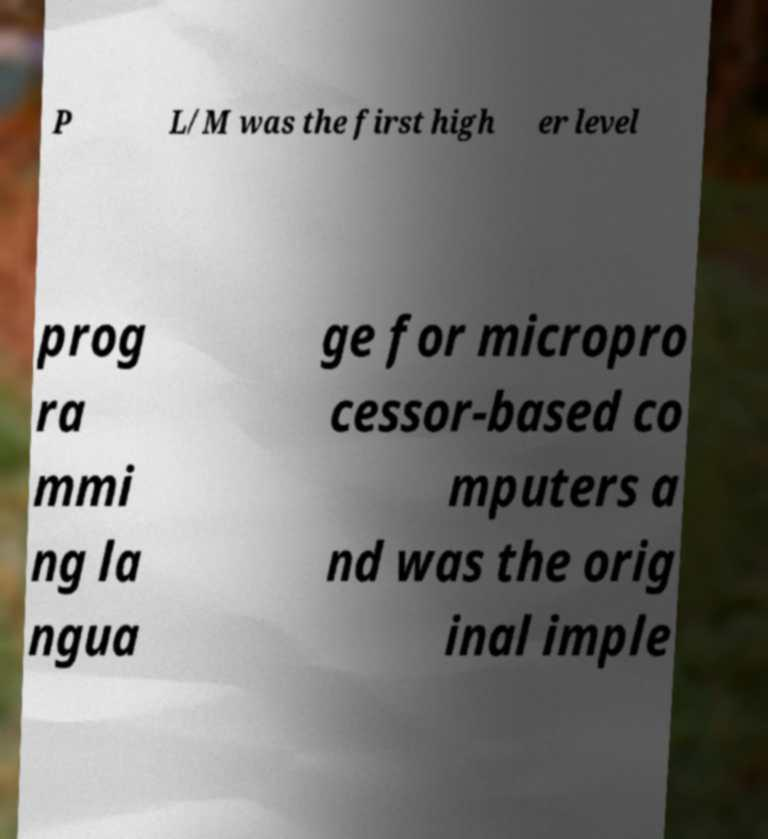Please read and relay the text visible in this image. What does it say? P L/M was the first high er level prog ra mmi ng la ngua ge for micropro cessor-based co mputers a nd was the orig inal imple 